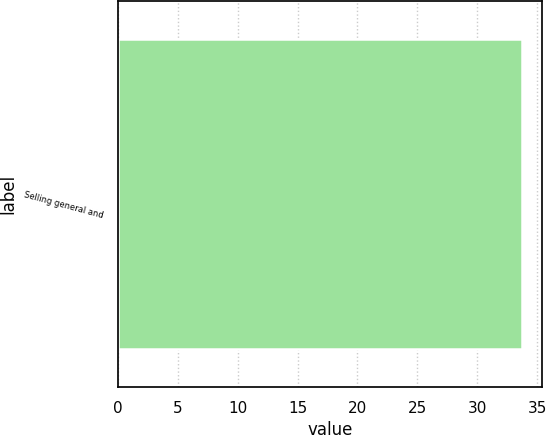Convert chart to OTSL. <chart><loc_0><loc_0><loc_500><loc_500><bar_chart><fcel>Selling general and<nl><fcel>33.7<nl></chart> 